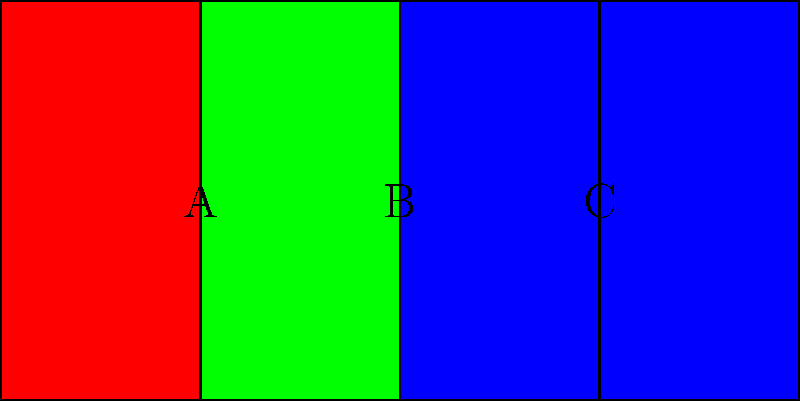In a traditional Eastern European folk costume embroidery pattern, three overlapping squares form a geometric design as shown above. If the area of square A is 1 square unit, what is the total area of the region where all three squares overlap (region B)? Let's approach this step-by-step:

1) First, we need to understand the geometry of the pattern. We have three squares of equal size, each overlapping the other two by half their width.

2) Given that the area of square A is 1 square unit, we can deduce that its side length is 1 unit.

3) Square B is formed by the overlap of all three squares. Its width is half that of the original squares.

4) To calculate the width of square B:
   - Width of B = $\frac{1}{2}$ width of A
   - Width of B = $\frac{1}{2} \times 1 = \frac{1}{2}$ unit

5) Now, to find the area of B, we square its width:
   Area of B = $(\frac{1}{2})^2 = \frac{1}{4}$ square unit

Therefore, the area of the region where all three squares overlap (region B) is $\frac{1}{4}$ square unit.
Answer: $\frac{1}{4}$ square unit 